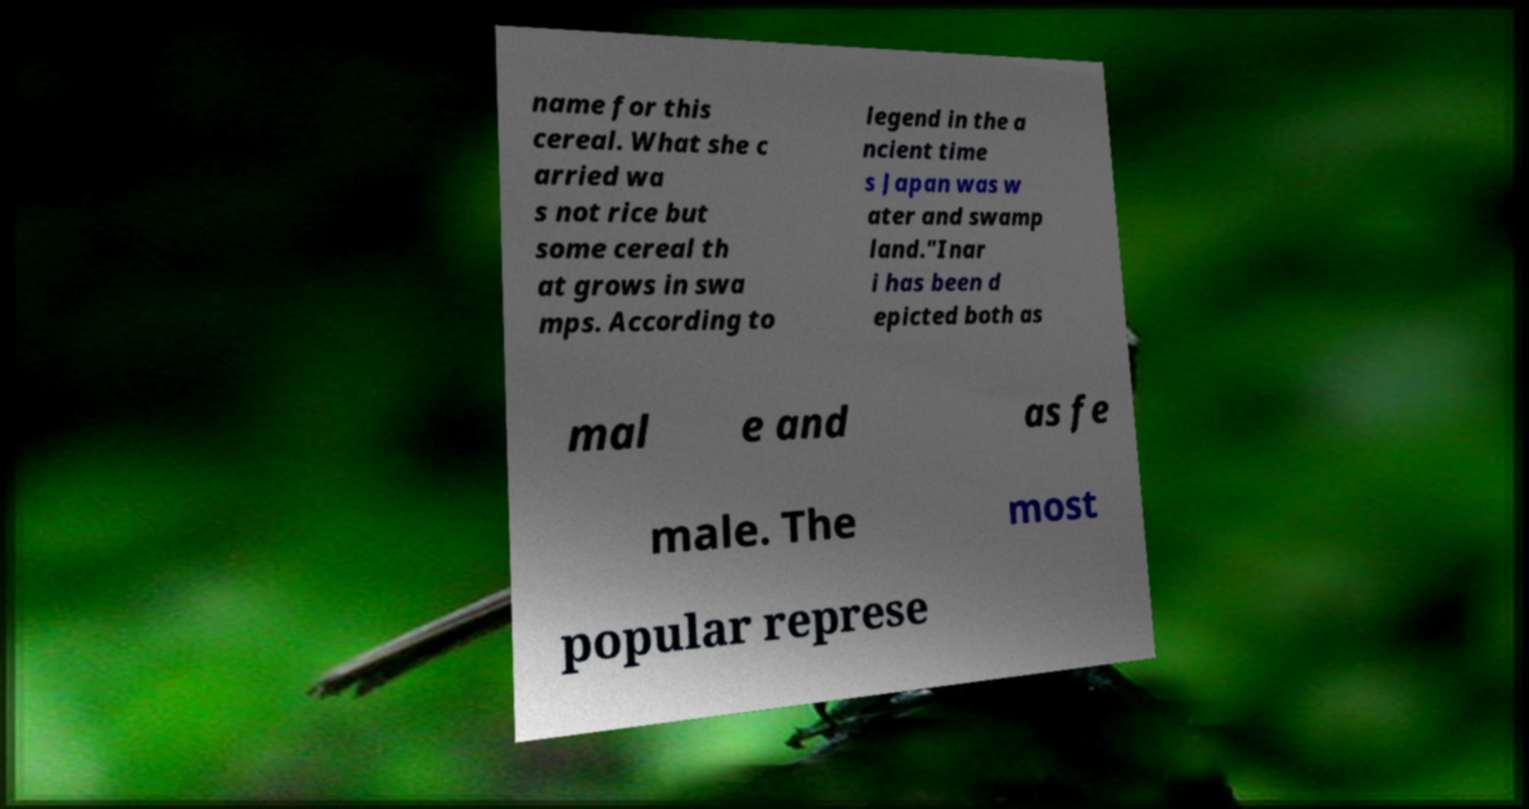Could you assist in decoding the text presented in this image and type it out clearly? name for this cereal. What she c arried wa s not rice but some cereal th at grows in swa mps. According to legend in the a ncient time s Japan was w ater and swamp land."Inar i has been d epicted both as mal e and as fe male. The most popular represe 